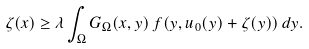Convert formula to latex. <formula><loc_0><loc_0><loc_500><loc_500>\zeta ( x ) \geq \lambda \int _ { \Omega } G _ { \Omega } ( x , y ) \, f ( y , u _ { 0 } ( y ) + \zeta ( y ) ) \, d y .</formula> 